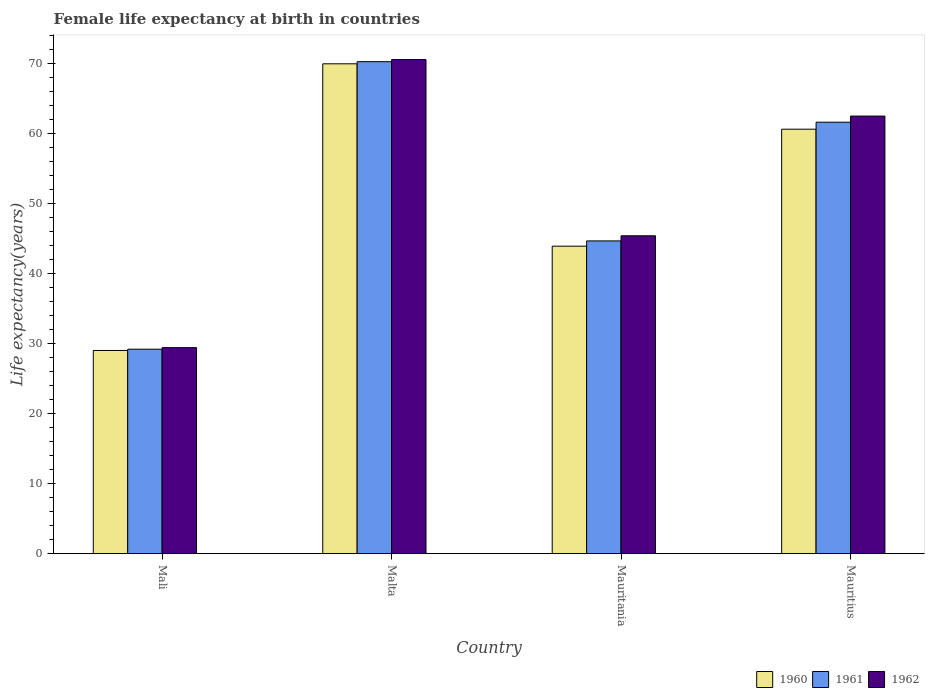How many different coloured bars are there?
Offer a very short reply. 3. How many groups of bars are there?
Keep it short and to the point. 4. Are the number of bars on each tick of the X-axis equal?
Make the answer very short. Yes. How many bars are there on the 4th tick from the left?
Provide a short and direct response. 3. What is the label of the 1st group of bars from the left?
Offer a terse response. Mali. In how many cases, is the number of bars for a given country not equal to the number of legend labels?
Give a very brief answer. 0. What is the female life expectancy at birth in 1962 in Malta?
Your answer should be compact. 70.57. Across all countries, what is the maximum female life expectancy at birth in 1960?
Provide a short and direct response. 69.96. Across all countries, what is the minimum female life expectancy at birth in 1962?
Keep it short and to the point. 29.43. In which country was the female life expectancy at birth in 1960 maximum?
Give a very brief answer. Malta. In which country was the female life expectancy at birth in 1960 minimum?
Provide a succinct answer. Mali. What is the total female life expectancy at birth in 1960 in the graph?
Your answer should be very brief. 203.53. What is the difference between the female life expectancy at birth in 1962 in Malta and that in Mauritius?
Your answer should be compact. 8.07. What is the difference between the female life expectancy at birth in 1962 in Mauritius and the female life expectancy at birth in 1961 in Malta?
Your answer should be compact. -7.77. What is the average female life expectancy at birth in 1962 per country?
Offer a very short reply. 51.98. What is the difference between the female life expectancy at birth of/in 1960 and female life expectancy at birth of/in 1961 in Mali?
Your response must be concise. -0.18. In how many countries, is the female life expectancy at birth in 1960 greater than 50 years?
Keep it short and to the point. 2. What is the ratio of the female life expectancy at birth in 1960 in Mali to that in Mauritius?
Provide a short and direct response. 0.48. What is the difference between the highest and the second highest female life expectancy at birth in 1960?
Offer a very short reply. -16.71. What is the difference between the highest and the lowest female life expectancy at birth in 1962?
Give a very brief answer. 41.13. In how many countries, is the female life expectancy at birth in 1962 greater than the average female life expectancy at birth in 1962 taken over all countries?
Provide a short and direct response. 2. Is the sum of the female life expectancy at birth in 1962 in Mali and Mauritania greater than the maximum female life expectancy at birth in 1960 across all countries?
Your answer should be very brief. Yes. Is it the case that in every country, the sum of the female life expectancy at birth in 1961 and female life expectancy at birth in 1960 is greater than the female life expectancy at birth in 1962?
Offer a terse response. Yes. How many bars are there?
Offer a very short reply. 12. How many countries are there in the graph?
Your answer should be compact. 4. What is the difference between two consecutive major ticks on the Y-axis?
Keep it short and to the point. 10. Does the graph contain any zero values?
Your answer should be very brief. No. How are the legend labels stacked?
Provide a succinct answer. Horizontal. What is the title of the graph?
Provide a succinct answer. Female life expectancy at birth in countries. What is the label or title of the X-axis?
Offer a very short reply. Country. What is the label or title of the Y-axis?
Give a very brief answer. Life expectancy(years). What is the Life expectancy(years) of 1960 in Mali?
Offer a terse response. 29.03. What is the Life expectancy(years) of 1961 in Mali?
Ensure brevity in your answer.  29.21. What is the Life expectancy(years) of 1962 in Mali?
Provide a succinct answer. 29.43. What is the Life expectancy(years) of 1960 in Malta?
Keep it short and to the point. 69.96. What is the Life expectancy(years) of 1961 in Malta?
Your answer should be very brief. 70.27. What is the Life expectancy(years) in 1962 in Malta?
Ensure brevity in your answer.  70.57. What is the Life expectancy(years) in 1960 in Mauritania?
Make the answer very short. 43.92. What is the Life expectancy(years) in 1961 in Mauritania?
Provide a short and direct response. 44.67. What is the Life expectancy(years) in 1962 in Mauritania?
Your response must be concise. 45.4. What is the Life expectancy(years) of 1960 in Mauritius?
Your answer should be compact. 60.63. What is the Life expectancy(years) in 1961 in Mauritius?
Offer a terse response. 61.62. What is the Life expectancy(years) of 1962 in Mauritius?
Provide a succinct answer. 62.5. Across all countries, what is the maximum Life expectancy(years) in 1960?
Your response must be concise. 69.96. Across all countries, what is the maximum Life expectancy(years) in 1961?
Your answer should be very brief. 70.27. Across all countries, what is the maximum Life expectancy(years) in 1962?
Keep it short and to the point. 70.57. Across all countries, what is the minimum Life expectancy(years) of 1960?
Provide a short and direct response. 29.03. Across all countries, what is the minimum Life expectancy(years) of 1961?
Make the answer very short. 29.21. Across all countries, what is the minimum Life expectancy(years) of 1962?
Provide a succinct answer. 29.43. What is the total Life expectancy(years) in 1960 in the graph?
Ensure brevity in your answer.  203.53. What is the total Life expectancy(years) of 1961 in the graph?
Your answer should be compact. 205.77. What is the total Life expectancy(years) in 1962 in the graph?
Give a very brief answer. 207.9. What is the difference between the Life expectancy(years) in 1960 in Mali and that in Malta?
Ensure brevity in your answer.  -40.94. What is the difference between the Life expectancy(years) of 1961 in Mali and that in Malta?
Your response must be concise. -41.06. What is the difference between the Life expectancy(years) of 1962 in Mali and that in Malta?
Your answer should be very brief. -41.13. What is the difference between the Life expectancy(years) of 1960 in Mali and that in Mauritania?
Your response must be concise. -14.89. What is the difference between the Life expectancy(years) of 1961 in Mali and that in Mauritania?
Give a very brief answer. -15.46. What is the difference between the Life expectancy(years) in 1962 in Mali and that in Mauritania?
Give a very brief answer. -15.97. What is the difference between the Life expectancy(years) in 1960 in Mali and that in Mauritius?
Offer a terse response. -31.6. What is the difference between the Life expectancy(years) in 1961 in Mali and that in Mauritius?
Your answer should be compact. -32.41. What is the difference between the Life expectancy(years) of 1962 in Mali and that in Mauritius?
Offer a terse response. -33.07. What is the difference between the Life expectancy(years) in 1960 in Malta and that in Mauritania?
Give a very brief answer. 26.04. What is the difference between the Life expectancy(years) of 1961 in Malta and that in Mauritania?
Provide a short and direct response. 25.6. What is the difference between the Life expectancy(years) in 1962 in Malta and that in Mauritania?
Make the answer very short. 25.16. What is the difference between the Life expectancy(years) in 1960 in Malta and that in Mauritius?
Your response must be concise. 9.34. What is the difference between the Life expectancy(years) of 1961 in Malta and that in Mauritius?
Make the answer very short. 8.64. What is the difference between the Life expectancy(years) of 1962 in Malta and that in Mauritius?
Your answer should be compact. 8.07. What is the difference between the Life expectancy(years) of 1960 in Mauritania and that in Mauritius?
Keep it short and to the point. -16.71. What is the difference between the Life expectancy(years) of 1961 in Mauritania and that in Mauritius?
Provide a short and direct response. -16.95. What is the difference between the Life expectancy(years) in 1962 in Mauritania and that in Mauritius?
Offer a terse response. -17.1. What is the difference between the Life expectancy(years) in 1960 in Mali and the Life expectancy(years) in 1961 in Malta?
Ensure brevity in your answer.  -41.24. What is the difference between the Life expectancy(years) of 1960 in Mali and the Life expectancy(years) of 1962 in Malta?
Keep it short and to the point. -41.54. What is the difference between the Life expectancy(years) of 1961 in Mali and the Life expectancy(years) of 1962 in Malta?
Your answer should be very brief. -41.36. What is the difference between the Life expectancy(years) in 1960 in Mali and the Life expectancy(years) in 1961 in Mauritania?
Give a very brief answer. -15.64. What is the difference between the Life expectancy(years) of 1960 in Mali and the Life expectancy(years) of 1962 in Mauritania?
Your answer should be compact. -16.38. What is the difference between the Life expectancy(years) in 1961 in Mali and the Life expectancy(years) in 1962 in Mauritania?
Offer a very short reply. -16.19. What is the difference between the Life expectancy(years) in 1960 in Mali and the Life expectancy(years) in 1961 in Mauritius?
Provide a short and direct response. -32.6. What is the difference between the Life expectancy(years) in 1960 in Mali and the Life expectancy(years) in 1962 in Mauritius?
Your answer should be compact. -33.47. What is the difference between the Life expectancy(years) of 1961 in Mali and the Life expectancy(years) of 1962 in Mauritius?
Give a very brief answer. -33.29. What is the difference between the Life expectancy(years) of 1960 in Malta and the Life expectancy(years) of 1961 in Mauritania?
Give a very brief answer. 25.29. What is the difference between the Life expectancy(years) in 1960 in Malta and the Life expectancy(years) in 1962 in Mauritania?
Ensure brevity in your answer.  24.56. What is the difference between the Life expectancy(years) of 1961 in Malta and the Life expectancy(years) of 1962 in Mauritania?
Provide a succinct answer. 24.86. What is the difference between the Life expectancy(years) of 1960 in Malta and the Life expectancy(years) of 1961 in Mauritius?
Offer a terse response. 8.34. What is the difference between the Life expectancy(years) in 1960 in Malta and the Life expectancy(years) in 1962 in Mauritius?
Provide a short and direct response. 7.46. What is the difference between the Life expectancy(years) of 1961 in Malta and the Life expectancy(years) of 1962 in Mauritius?
Your answer should be very brief. 7.77. What is the difference between the Life expectancy(years) in 1960 in Mauritania and the Life expectancy(years) in 1961 in Mauritius?
Give a very brief answer. -17.7. What is the difference between the Life expectancy(years) in 1960 in Mauritania and the Life expectancy(years) in 1962 in Mauritius?
Offer a terse response. -18.58. What is the difference between the Life expectancy(years) of 1961 in Mauritania and the Life expectancy(years) of 1962 in Mauritius?
Give a very brief answer. -17.83. What is the average Life expectancy(years) in 1960 per country?
Offer a terse response. 50.88. What is the average Life expectancy(years) in 1961 per country?
Provide a succinct answer. 51.44. What is the average Life expectancy(years) in 1962 per country?
Offer a very short reply. 51.98. What is the difference between the Life expectancy(years) of 1960 and Life expectancy(years) of 1961 in Mali?
Ensure brevity in your answer.  -0.18. What is the difference between the Life expectancy(years) of 1960 and Life expectancy(years) of 1962 in Mali?
Your answer should be compact. -0.41. What is the difference between the Life expectancy(years) in 1961 and Life expectancy(years) in 1962 in Mali?
Offer a terse response. -0.22. What is the difference between the Life expectancy(years) of 1960 and Life expectancy(years) of 1961 in Malta?
Ensure brevity in your answer.  -0.3. What is the difference between the Life expectancy(years) in 1960 and Life expectancy(years) in 1962 in Malta?
Ensure brevity in your answer.  -0.6. What is the difference between the Life expectancy(years) in 1961 and Life expectancy(years) in 1962 in Malta?
Your response must be concise. -0.3. What is the difference between the Life expectancy(years) in 1960 and Life expectancy(years) in 1961 in Mauritania?
Offer a very short reply. -0.75. What is the difference between the Life expectancy(years) in 1960 and Life expectancy(years) in 1962 in Mauritania?
Offer a very short reply. -1.48. What is the difference between the Life expectancy(years) in 1961 and Life expectancy(years) in 1962 in Mauritania?
Give a very brief answer. -0.73. What is the difference between the Life expectancy(years) of 1960 and Life expectancy(years) of 1961 in Mauritius?
Your response must be concise. -1. What is the difference between the Life expectancy(years) in 1960 and Life expectancy(years) in 1962 in Mauritius?
Make the answer very short. -1.87. What is the difference between the Life expectancy(years) in 1961 and Life expectancy(years) in 1962 in Mauritius?
Provide a short and direct response. -0.88. What is the ratio of the Life expectancy(years) of 1960 in Mali to that in Malta?
Make the answer very short. 0.41. What is the ratio of the Life expectancy(years) of 1961 in Mali to that in Malta?
Make the answer very short. 0.42. What is the ratio of the Life expectancy(years) of 1962 in Mali to that in Malta?
Offer a terse response. 0.42. What is the ratio of the Life expectancy(years) in 1960 in Mali to that in Mauritania?
Provide a short and direct response. 0.66. What is the ratio of the Life expectancy(years) of 1961 in Mali to that in Mauritania?
Provide a short and direct response. 0.65. What is the ratio of the Life expectancy(years) in 1962 in Mali to that in Mauritania?
Provide a succinct answer. 0.65. What is the ratio of the Life expectancy(years) of 1960 in Mali to that in Mauritius?
Keep it short and to the point. 0.48. What is the ratio of the Life expectancy(years) of 1961 in Mali to that in Mauritius?
Ensure brevity in your answer.  0.47. What is the ratio of the Life expectancy(years) of 1962 in Mali to that in Mauritius?
Provide a short and direct response. 0.47. What is the ratio of the Life expectancy(years) of 1960 in Malta to that in Mauritania?
Your response must be concise. 1.59. What is the ratio of the Life expectancy(years) of 1961 in Malta to that in Mauritania?
Your answer should be very brief. 1.57. What is the ratio of the Life expectancy(years) of 1962 in Malta to that in Mauritania?
Keep it short and to the point. 1.55. What is the ratio of the Life expectancy(years) in 1960 in Malta to that in Mauritius?
Your response must be concise. 1.15. What is the ratio of the Life expectancy(years) in 1961 in Malta to that in Mauritius?
Provide a short and direct response. 1.14. What is the ratio of the Life expectancy(years) in 1962 in Malta to that in Mauritius?
Ensure brevity in your answer.  1.13. What is the ratio of the Life expectancy(years) in 1960 in Mauritania to that in Mauritius?
Offer a terse response. 0.72. What is the ratio of the Life expectancy(years) of 1961 in Mauritania to that in Mauritius?
Ensure brevity in your answer.  0.72. What is the ratio of the Life expectancy(years) of 1962 in Mauritania to that in Mauritius?
Offer a very short reply. 0.73. What is the difference between the highest and the second highest Life expectancy(years) of 1960?
Make the answer very short. 9.34. What is the difference between the highest and the second highest Life expectancy(years) in 1961?
Offer a very short reply. 8.64. What is the difference between the highest and the second highest Life expectancy(years) in 1962?
Your answer should be compact. 8.07. What is the difference between the highest and the lowest Life expectancy(years) of 1960?
Make the answer very short. 40.94. What is the difference between the highest and the lowest Life expectancy(years) of 1961?
Provide a short and direct response. 41.06. What is the difference between the highest and the lowest Life expectancy(years) of 1962?
Provide a succinct answer. 41.13. 